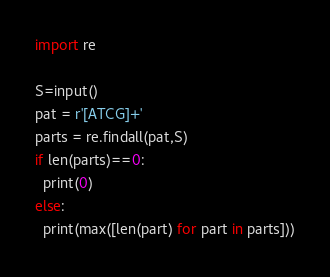<code> <loc_0><loc_0><loc_500><loc_500><_Python_>import re

S=input()
pat = r'[ATCG]+'
parts = re.findall(pat,S)
if len(parts)==0:
  print(0) 
else:
  print(max([len(part) for part in parts]))</code> 